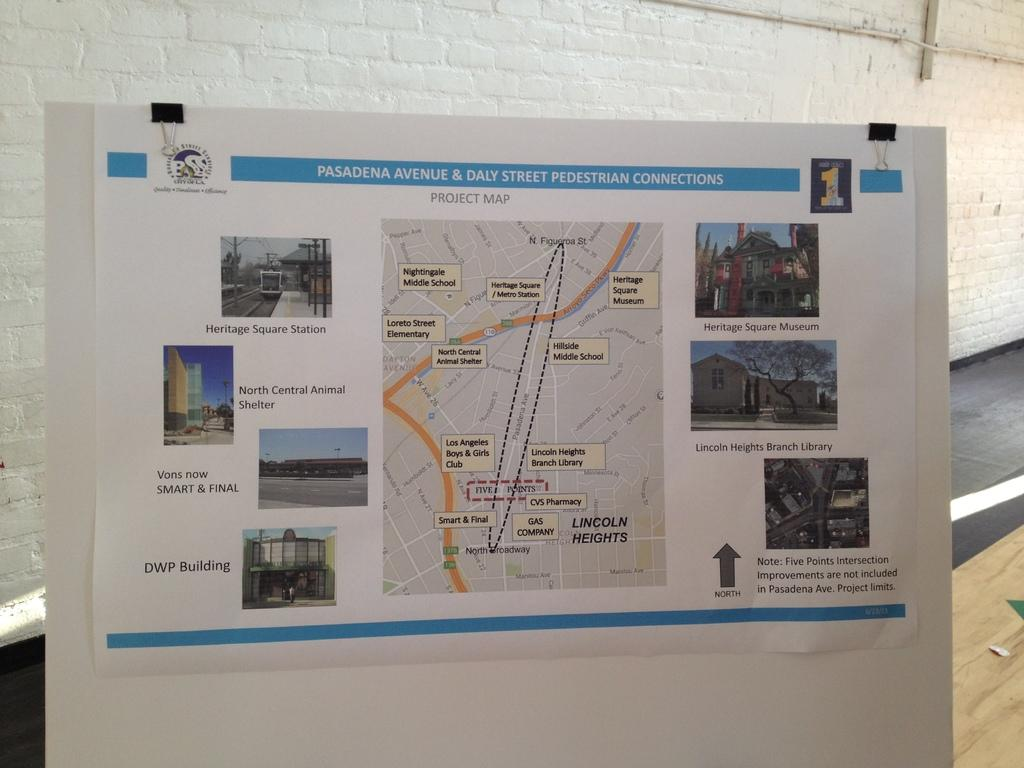<image>
Present a compact description of the photo's key features. A google map of Pasadena Avenue and Daily street from the pedestrian view. 